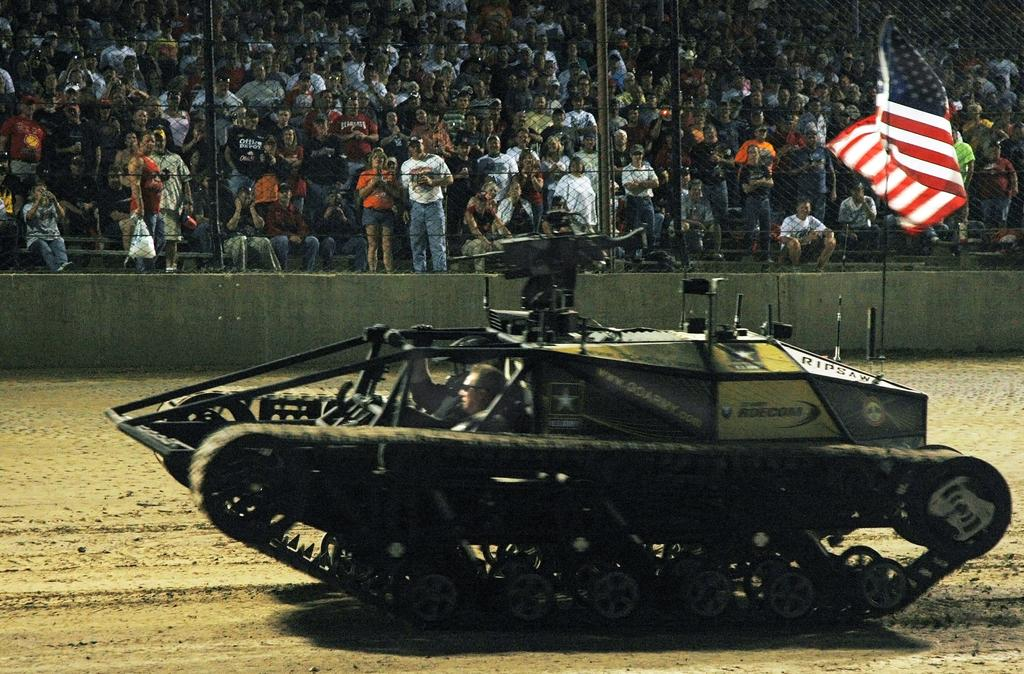What type of vehicle is on the ground in the image? There is a war tank on the ground in the image. What can be seen flying in the image? There is a flag in the image. Where is the flag attached in the image? There is a flag post in the image. What are the people in the image doing? There are spectators sitting and standing in the image. What type of wine is being served to the ladybug in the image? There is no ladybug or wine present in the image. 